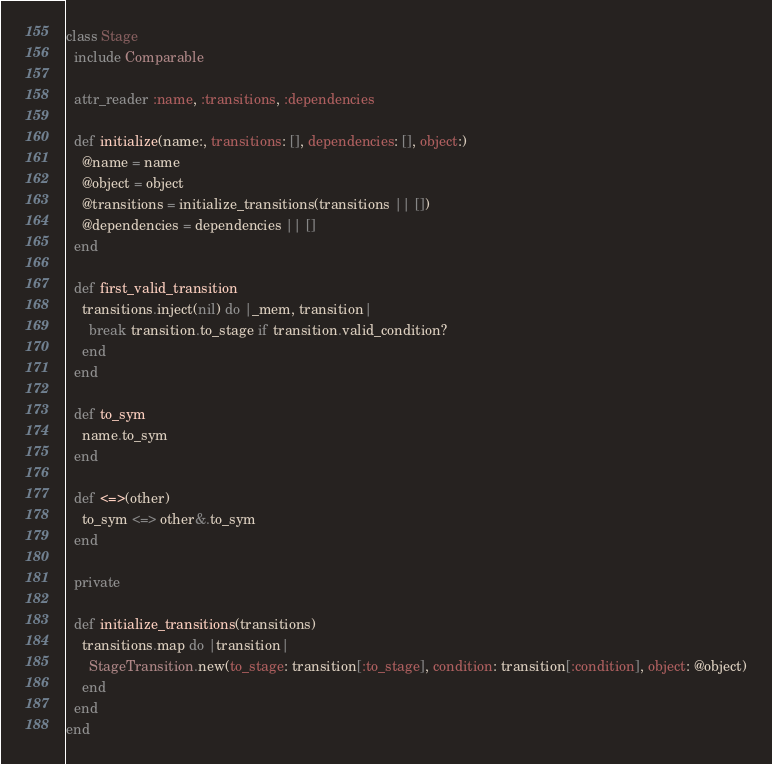Convert code to text. <code><loc_0><loc_0><loc_500><loc_500><_Ruby_>class Stage
  include Comparable

  attr_reader :name, :transitions, :dependencies

  def initialize(name:, transitions: [], dependencies: [], object:)
    @name = name
    @object = object
    @transitions = initialize_transitions(transitions || [])
    @dependencies = dependencies || []
  end

  def first_valid_transition
    transitions.inject(nil) do |_mem, transition|
      break transition.to_stage if transition.valid_condition?
    end
  end

  def to_sym
    name.to_sym
  end

  def <=>(other)
    to_sym <=> other&.to_sym
  end

  private

  def initialize_transitions(transitions)
    transitions.map do |transition|
      StageTransition.new(to_stage: transition[:to_stage], condition: transition[:condition], object: @object)
    end
  end
end
</code> 